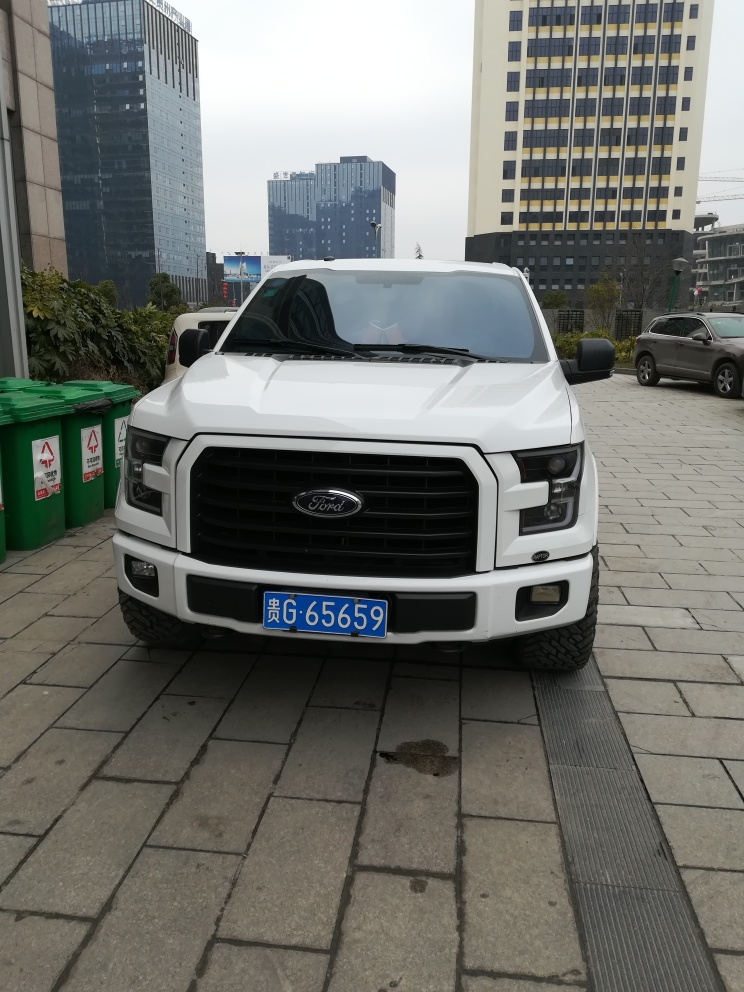What can be said about the quality of the photo? The quality of the photo is average. The image is clear enough to discern details like the make of the vehicle and license plate number. However, the lighting is flat and lacks depth, and there's no dynamic range or artistic composition. 